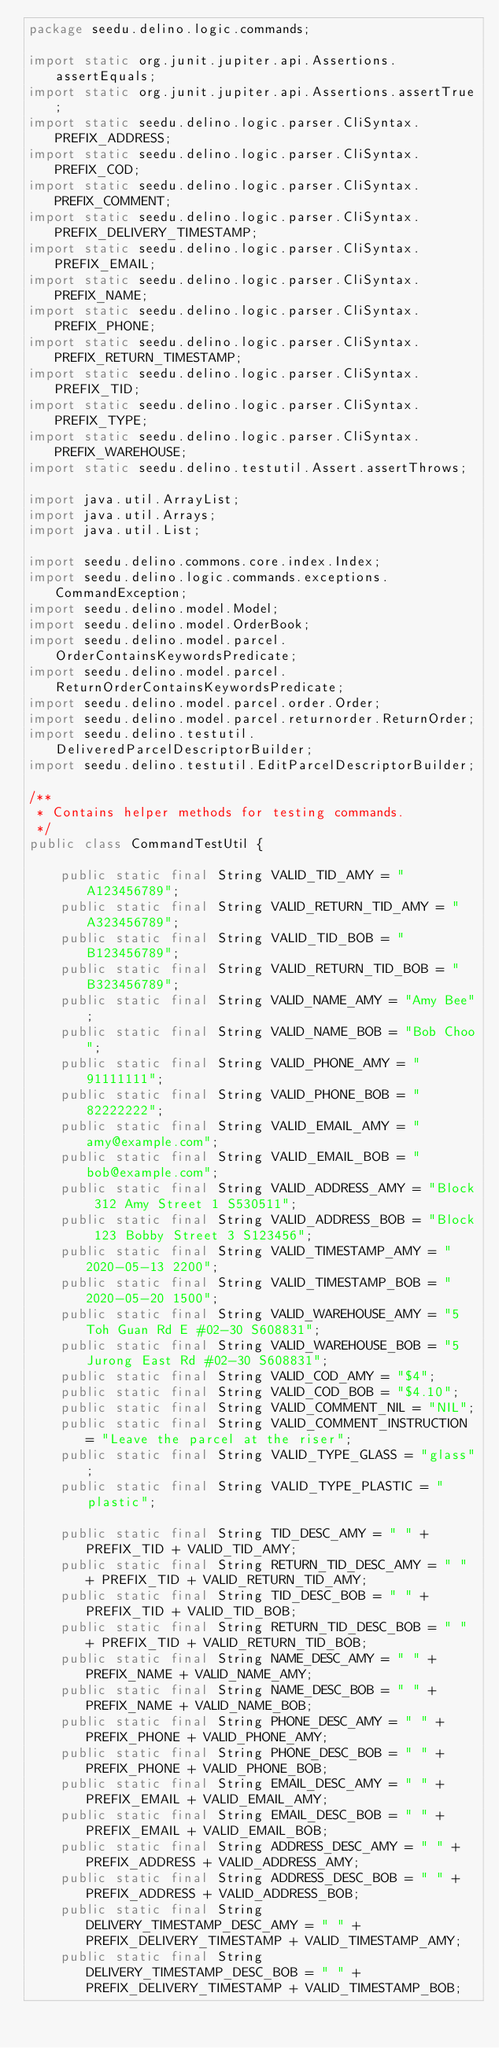Convert code to text. <code><loc_0><loc_0><loc_500><loc_500><_Java_>package seedu.delino.logic.commands;

import static org.junit.jupiter.api.Assertions.assertEquals;
import static org.junit.jupiter.api.Assertions.assertTrue;
import static seedu.delino.logic.parser.CliSyntax.PREFIX_ADDRESS;
import static seedu.delino.logic.parser.CliSyntax.PREFIX_COD;
import static seedu.delino.logic.parser.CliSyntax.PREFIX_COMMENT;
import static seedu.delino.logic.parser.CliSyntax.PREFIX_DELIVERY_TIMESTAMP;
import static seedu.delino.logic.parser.CliSyntax.PREFIX_EMAIL;
import static seedu.delino.logic.parser.CliSyntax.PREFIX_NAME;
import static seedu.delino.logic.parser.CliSyntax.PREFIX_PHONE;
import static seedu.delino.logic.parser.CliSyntax.PREFIX_RETURN_TIMESTAMP;
import static seedu.delino.logic.parser.CliSyntax.PREFIX_TID;
import static seedu.delino.logic.parser.CliSyntax.PREFIX_TYPE;
import static seedu.delino.logic.parser.CliSyntax.PREFIX_WAREHOUSE;
import static seedu.delino.testutil.Assert.assertThrows;

import java.util.ArrayList;
import java.util.Arrays;
import java.util.List;

import seedu.delino.commons.core.index.Index;
import seedu.delino.logic.commands.exceptions.CommandException;
import seedu.delino.model.Model;
import seedu.delino.model.OrderBook;
import seedu.delino.model.parcel.OrderContainsKeywordsPredicate;
import seedu.delino.model.parcel.ReturnOrderContainsKeywordsPredicate;
import seedu.delino.model.parcel.order.Order;
import seedu.delino.model.parcel.returnorder.ReturnOrder;
import seedu.delino.testutil.DeliveredParcelDescriptorBuilder;
import seedu.delino.testutil.EditParcelDescriptorBuilder;

/**
 * Contains helper methods for testing commands.
 */
public class CommandTestUtil {

    public static final String VALID_TID_AMY = "A123456789";
    public static final String VALID_RETURN_TID_AMY = "A323456789";
    public static final String VALID_TID_BOB = "B123456789";
    public static final String VALID_RETURN_TID_BOB = "B323456789";
    public static final String VALID_NAME_AMY = "Amy Bee";
    public static final String VALID_NAME_BOB = "Bob Choo";
    public static final String VALID_PHONE_AMY = "91111111";
    public static final String VALID_PHONE_BOB = "82222222";
    public static final String VALID_EMAIL_AMY = "amy@example.com";
    public static final String VALID_EMAIL_BOB = "bob@example.com";
    public static final String VALID_ADDRESS_AMY = "Block 312 Amy Street 1 S530511";
    public static final String VALID_ADDRESS_BOB = "Block 123 Bobby Street 3 S123456";
    public static final String VALID_TIMESTAMP_AMY = "2020-05-13 2200";
    public static final String VALID_TIMESTAMP_BOB = "2020-05-20 1500";
    public static final String VALID_WAREHOUSE_AMY = "5 Toh Guan Rd E #02-30 S608831";
    public static final String VALID_WAREHOUSE_BOB = "5 Jurong East Rd #02-30 S608831";
    public static final String VALID_COD_AMY = "$4";
    public static final String VALID_COD_BOB = "$4.10";
    public static final String VALID_COMMENT_NIL = "NIL";
    public static final String VALID_COMMENT_INSTRUCTION = "Leave the parcel at the riser";
    public static final String VALID_TYPE_GLASS = "glass";
    public static final String VALID_TYPE_PLASTIC = "plastic";

    public static final String TID_DESC_AMY = " " + PREFIX_TID + VALID_TID_AMY;
    public static final String RETURN_TID_DESC_AMY = " " + PREFIX_TID + VALID_RETURN_TID_AMY;
    public static final String TID_DESC_BOB = " " + PREFIX_TID + VALID_TID_BOB;
    public static final String RETURN_TID_DESC_BOB = " " + PREFIX_TID + VALID_RETURN_TID_BOB;
    public static final String NAME_DESC_AMY = " " + PREFIX_NAME + VALID_NAME_AMY;
    public static final String NAME_DESC_BOB = " " + PREFIX_NAME + VALID_NAME_BOB;
    public static final String PHONE_DESC_AMY = " " + PREFIX_PHONE + VALID_PHONE_AMY;
    public static final String PHONE_DESC_BOB = " " + PREFIX_PHONE + VALID_PHONE_BOB;
    public static final String EMAIL_DESC_AMY = " " + PREFIX_EMAIL + VALID_EMAIL_AMY;
    public static final String EMAIL_DESC_BOB = " " + PREFIX_EMAIL + VALID_EMAIL_BOB;
    public static final String ADDRESS_DESC_AMY = " " + PREFIX_ADDRESS + VALID_ADDRESS_AMY;
    public static final String ADDRESS_DESC_BOB = " " + PREFIX_ADDRESS + VALID_ADDRESS_BOB;
    public static final String DELIVERY_TIMESTAMP_DESC_AMY = " " + PREFIX_DELIVERY_TIMESTAMP + VALID_TIMESTAMP_AMY;
    public static final String DELIVERY_TIMESTAMP_DESC_BOB = " " + PREFIX_DELIVERY_TIMESTAMP + VALID_TIMESTAMP_BOB;</code> 